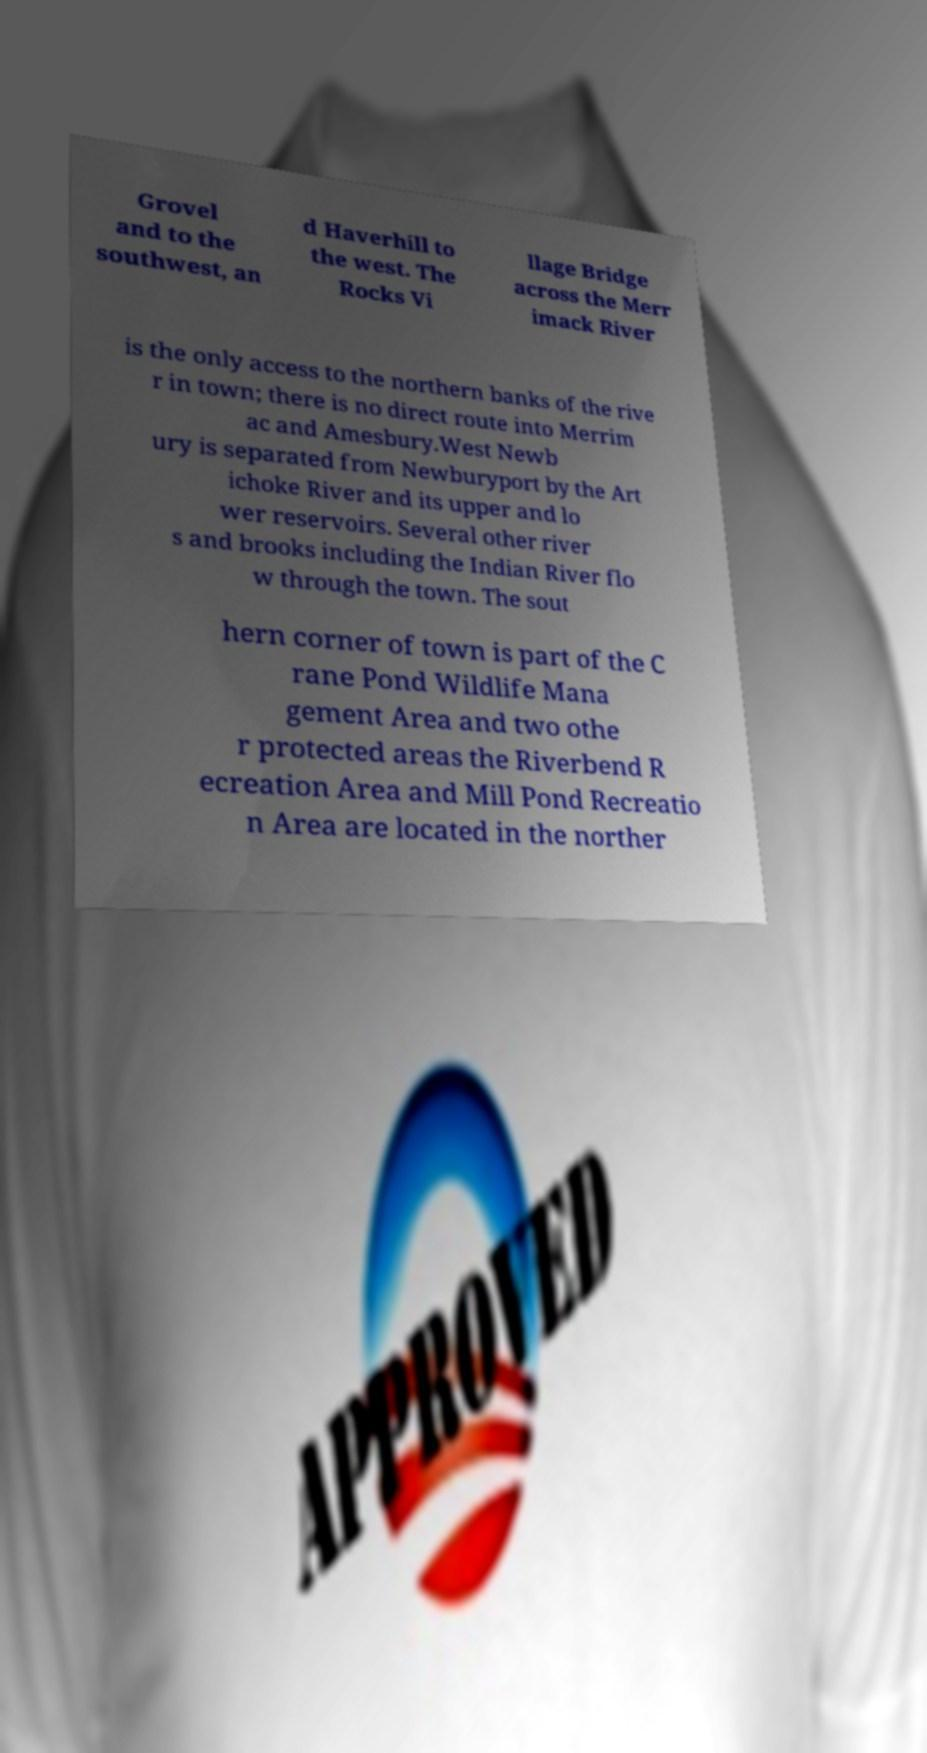There's text embedded in this image that I need extracted. Can you transcribe it verbatim? Grovel and to the southwest, an d Haverhill to the west. The Rocks Vi llage Bridge across the Merr imack River is the only access to the northern banks of the rive r in town; there is no direct route into Merrim ac and Amesbury.West Newb ury is separated from Newburyport by the Art ichoke River and its upper and lo wer reservoirs. Several other river s and brooks including the Indian River flo w through the town. The sout hern corner of town is part of the C rane Pond Wildlife Mana gement Area and two othe r protected areas the Riverbend R ecreation Area and Mill Pond Recreatio n Area are located in the norther 